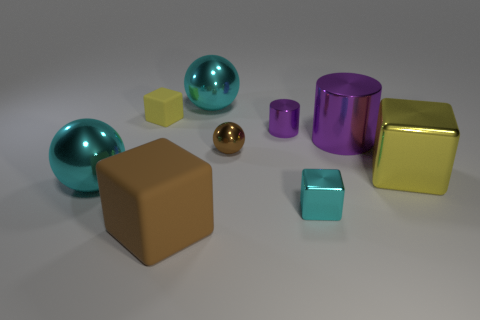Subtract all tiny balls. How many balls are left? 2 Subtract all yellow blocks. How many blocks are left? 2 Add 1 large things. How many objects exist? 10 Subtract 3 balls. How many balls are left? 0 Subtract all cylinders. How many objects are left? 7 Subtract all brown spheres. Subtract all gray cylinders. How many spheres are left? 2 Subtract all purple cylinders. How many brown cubes are left? 1 Subtract all tiny purple metal things. Subtract all tiny things. How many objects are left? 4 Add 6 yellow objects. How many yellow objects are left? 8 Add 7 small purple objects. How many small purple objects exist? 8 